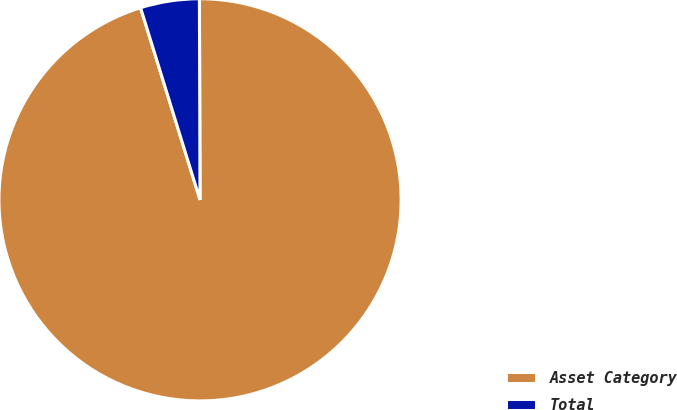Convert chart to OTSL. <chart><loc_0><loc_0><loc_500><loc_500><pie_chart><fcel>Asset Category<fcel>Total<nl><fcel>95.27%<fcel>4.73%<nl></chart> 